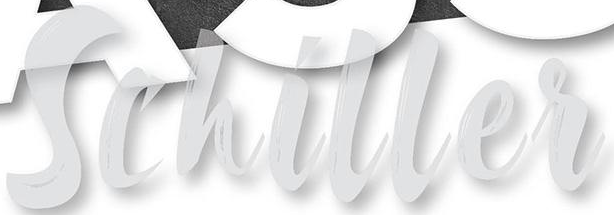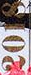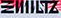What words are shown in these images in order, separated by a semicolon? Schiller; 2018; ΞIIIILTZ 